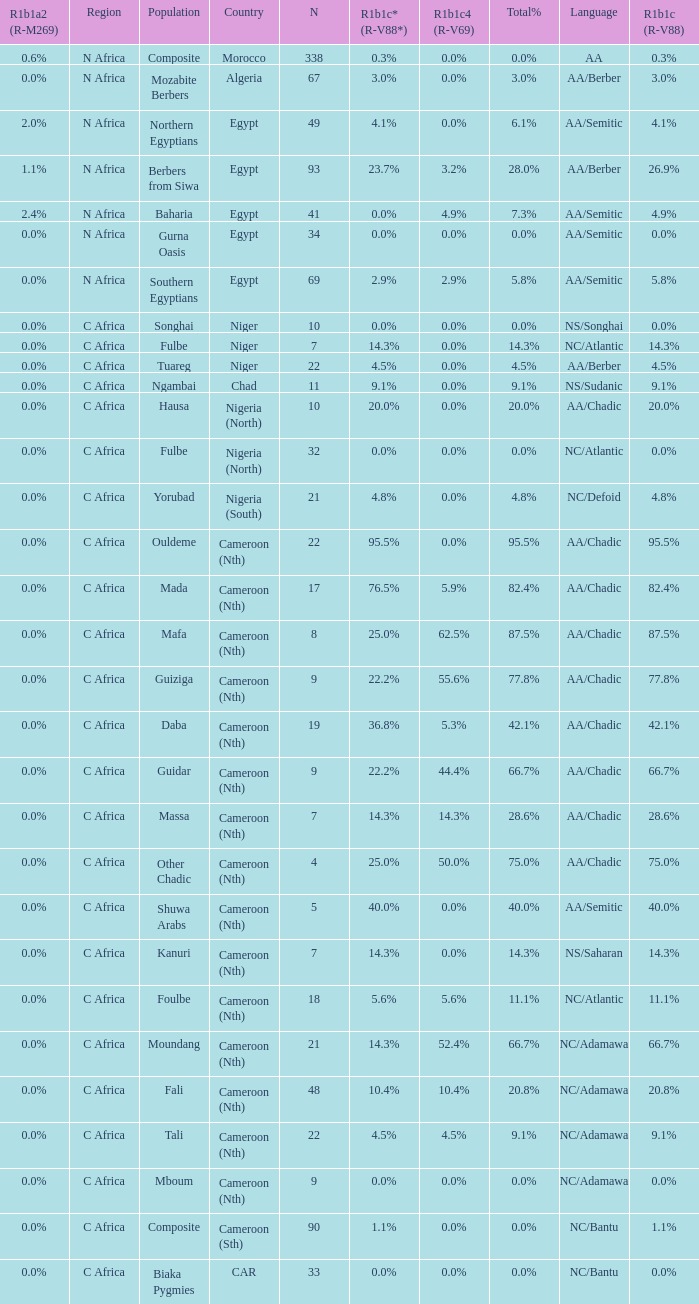What are the languages spoken in niger that have a 0.0% r1b1c (r-v88) frequency? NS/Songhai. 